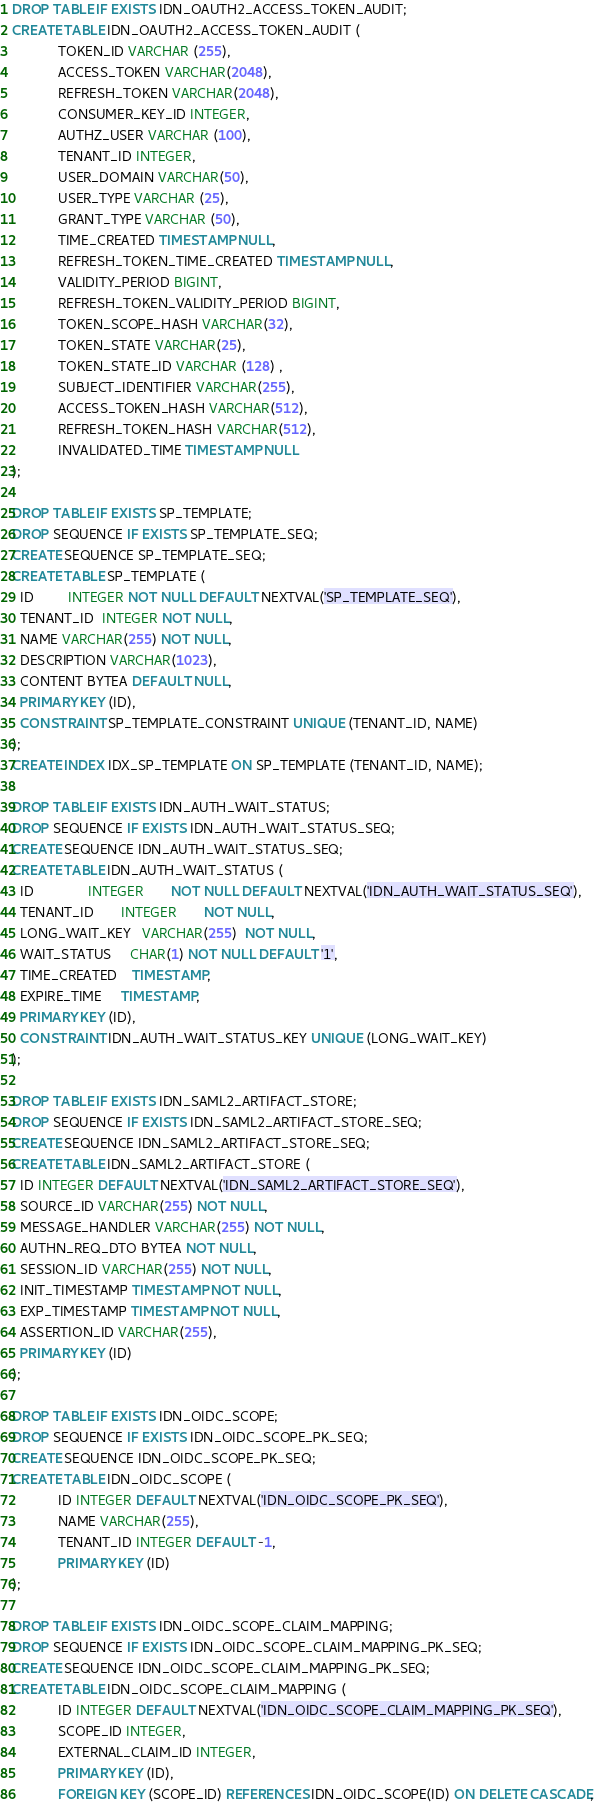<code> <loc_0><loc_0><loc_500><loc_500><_SQL_>DROP TABLE IF EXISTS IDN_OAUTH2_ACCESS_TOKEN_AUDIT;
CREATE TABLE IDN_OAUTH2_ACCESS_TOKEN_AUDIT (
            TOKEN_ID VARCHAR (255),
            ACCESS_TOKEN VARCHAR(2048),
            REFRESH_TOKEN VARCHAR(2048),
            CONSUMER_KEY_ID INTEGER,
            AUTHZ_USER VARCHAR (100),
            TENANT_ID INTEGER,
            USER_DOMAIN VARCHAR(50),
            USER_TYPE VARCHAR (25),
            GRANT_TYPE VARCHAR (50),
            TIME_CREATED TIMESTAMP NULL,
            REFRESH_TOKEN_TIME_CREATED TIMESTAMP NULL,
            VALIDITY_PERIOD BIGINT,
            REFRESH_TOKEN_VALIDITY_PERIOD BIGINT,
            TOKEN_SCOPE_HASH VARCHAR(32),
            TOKEN_STATE VARCHAR(25),
            TOKEN_STATE_ID VARCHAR (128) ,
            SUBJECT_IDENTIFIER VARCHAR(255),
            ACCESS_TOKEN_HASH VARCHAR(512),
            REFRESH_TOKEN_HASH VARCHAR(512),
            INVALIDATED_TIME TIMESTAMP NULL
);

DROP TABLE IF EXISTS SP_TEMPLATE;
DROP SEQUENCE IF EXISTS SP_TEMPLATE_SEQ;
CREATE SEQUENCE SP_TEMPLATE_SEQ;
CREATE TABLE SP_TEMPLATE (
  ID         INTEGER NOT NULL DEFAULT NEXTVAL('SP_TEMPLATE_SEQ'),
  TENANT_ID  INTEGER NOT NULL,
  NAME VARCHAR(255) NOT NULL,
  DESCRIPTION VARCHAR(1023),
  CONTENT BYTEA DEFAULT NULL,
  PRIMARY KEY (ID),
  CONSTRAINT SP_TEMPLATE_CONSTRAINT UNIQUE (TENANT_ID, NAME)
);
CREATE INDEX IDX_SP_TEMPLATE ON SP_TEMPLATE (TENANT_ID, NAME);

DROP TABLE IF EXISTS IDN_AUTH_WAIT_STATUS;
DROP SEQUENCE IF EXISTS IDN_AUTH_WAIT_STATUS_SEQ;
CREATE SEQUENCE IDN_AUTH_WAIT_STATUS_SEQ;
CREATE TABLE IDN_AUTH_WAIT_STATUS (
  ID              INTEGER       NOT NULL DEFAULT NEXTVAL('IDN_AUTH_WAIT_STATUS_SEQ'),
  TENANT_ID       INTEGER       NOT NULL,
  LONG_WAIT_KEY   VARCHAR(255)  NOT NULL,
  WAIT_STATUS     CHAR(1) NOT NULL DEFAULT '1',
  TIME_CREATED    TIMESTAMP,
  EXPIRE_TIME     TIMESTAMP,
  PRIMARY KEY (ID),
  CONSTRAINT IDN_AUTH_WAIT_STATUS_KEY UNIQUE (LONG_WAIT_KEY)
);

DROP TABLE IF EXISTS IDN_SAML2_ARTIFACT_STORE;
DROP SEQUENCE IF EXISTS IDN_SAML2_ARTIFACT_STORE_SEQ;
CREATE SEQUENCE IDN_SAML2_ARTIFACT_STORE_SEQ;
CREATE TABLE IDN_SAML2_ARTIFACT_STORE (
  ID INTEGER DEFAULT NEXTVAL('IDN_SAML2_ARTIFACT_STORE_SEQ'),
  SOURCE_ID VARCHAR(255) NOT NULL,
  MESSAGE_HANDLER VARCHAR(255) NOT NULL,
  AUTHN_REQ_DTO BYTEA NOT NULL,
  SESSION_ID VARCHAR(255) NOT NULL,
  INIT_TIMESTAMP TIMESTAMP NOT NULL,
  EXP_TIMESTAMP TIMESTAMP NOT NULL,
  ASSERTION_ID VARCHAR(255),
  PRIMARY KEY (ID)
);

DROP TABLE IF EXISTS IDN_OIDC_SCOPE;
DROP SEQUENCE IF EXISTS IDN_OIDC_SCOPE_PK_SEQ;
CREATE SEQUENCE IDN_OIDC_SCOPE_PK_SEQ;
CREATE TABLE IDN_OIDC_SCOPE (
            ID INTEGER DEFAULT NEXTVAL('IDN_OIDC_SCOPE_PK_SEQ'),
            NAME VARCHAR(255),
            TENANT_ID INTEGER DEFAULT -1,
            PRIMARY KEY (ID)
);

DROP TABLE IF EXISTS IDN_OIDC_SCOPE_CLAIM_MAPPING;
DROP SEQUENCE IF EXISTS IDN_OIDC_SCOPE_CLAIM_MAPPING_PK_SEQ;
CREATE SEQUENCE IDN_OIDC_SCOPE_CLAIM_MAPPING_PK_SEQ;
CREATE TABLE IDN_OIDC_SCOPE_CLAIM_MAPPING (
            ID INTEGER DEFAULT NEXTVAL('IDN_OIDC_SCOPE_CLAIM_MAPPING_PK_SEQ'),
            SCOPE_ID INTEGER,
            EXTERNAL_CLAIM_ID INTEGER,
            PRIMARY KEY (ID),
            FOREIGN KEY (SCOPE_ID) REFERENCES IDN_OIDC_SCOPE(ID) ON DELETE CASCADE,</code> 